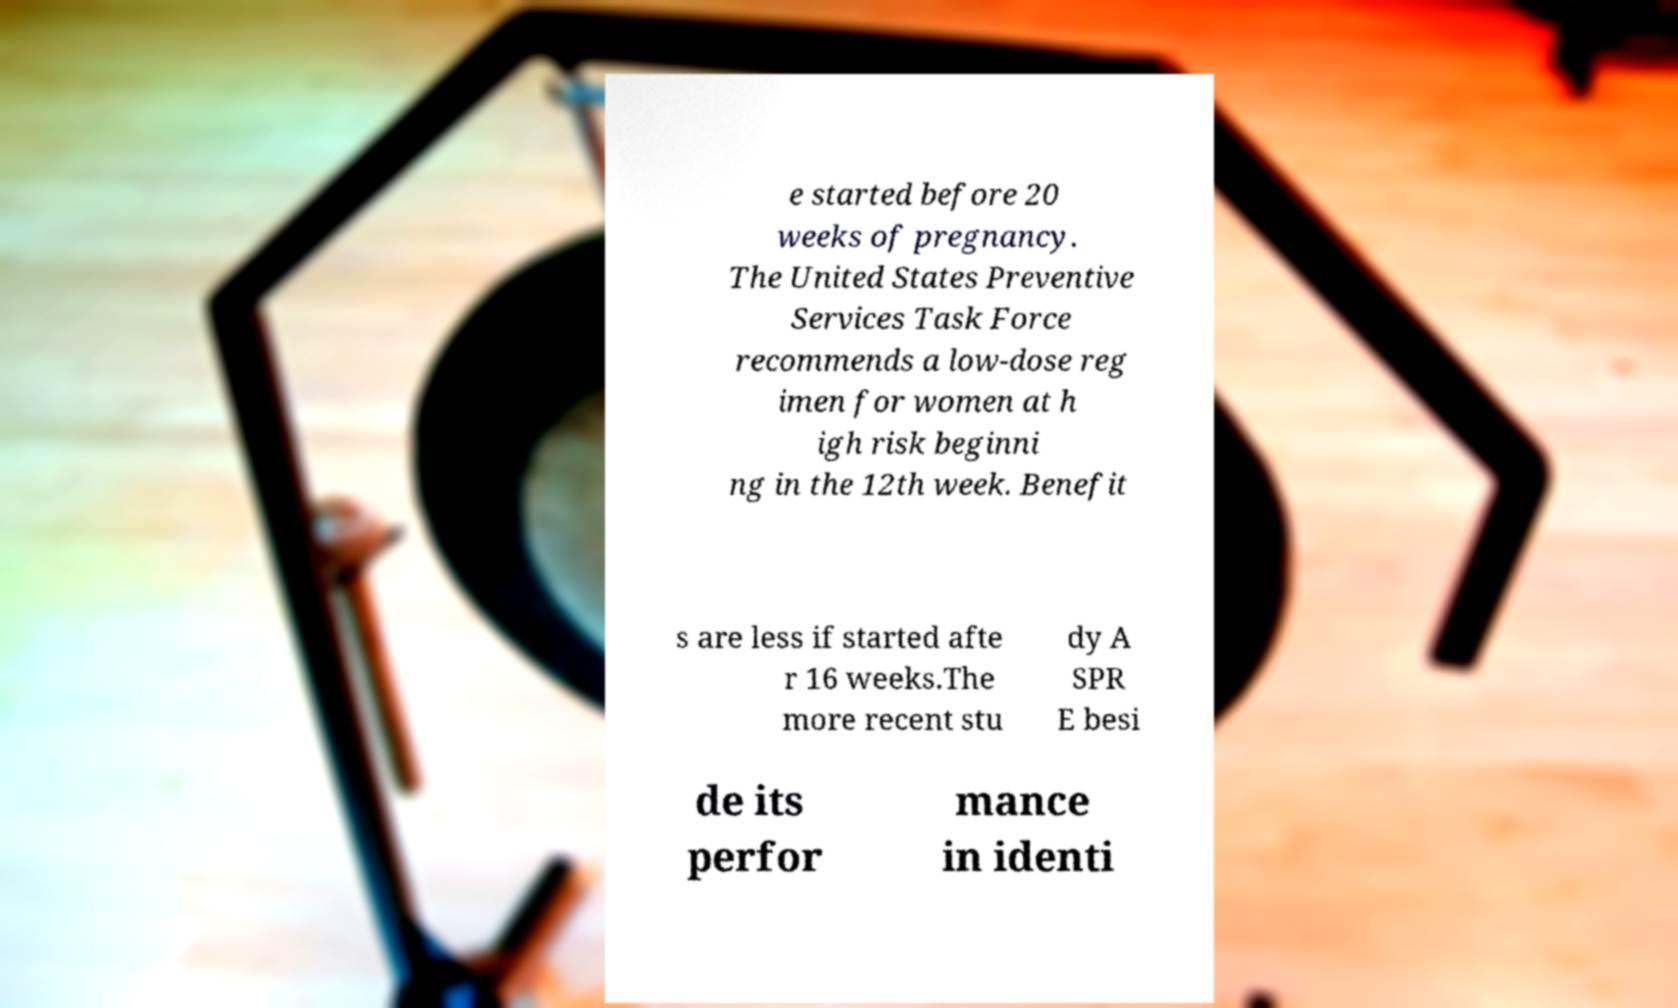Please read and relay the text visible in this image. What does it say? e started before 20 weeks of pregnancy. The United States Preventive Services Task Force recommends a low-dose reg imen for women at h igh risk beginni ng in the 12th week. Benefit s are less if started afte r 16 weeks.The more recent stu dy A SPR E besi de its perfor mance in identi 